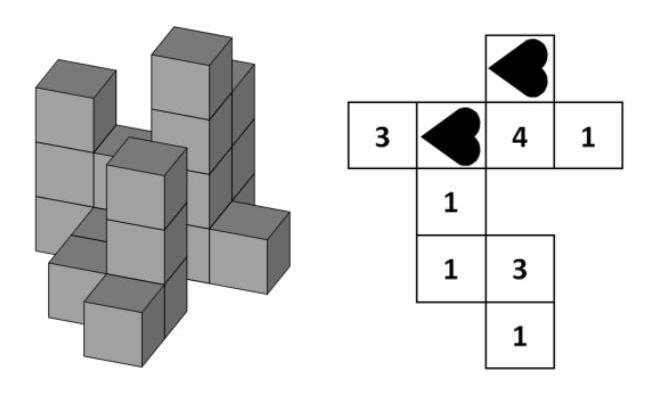Regarding the two numbers not covered by hearts, what is their total sum, and can we ascertain why these positions are important? The numbers not covered by hearts in the image are '4' and '3'. Adding these numbers gives a total sum of 7. These positions likely represent towers of greater significance or prominence, possibly due to their strategic placements or height. 